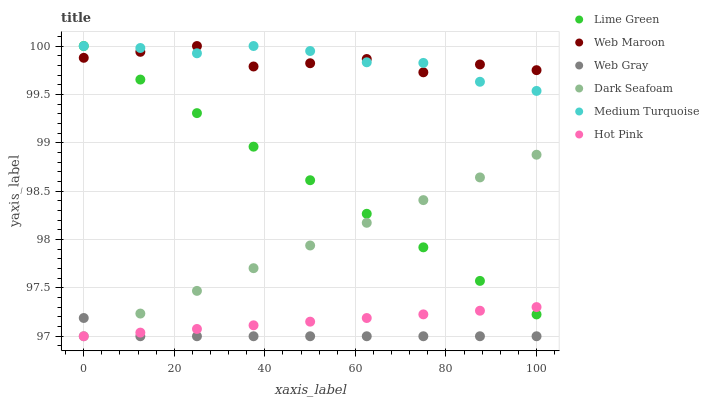Does Web Gray have the minimum area under the curve?
Answer yes or no. Yes. Does Medium Turquoise have the maximum area under the curve?
Answer yes or no. Yes. Does Hot Pink have the minimum area under the curve?
Answer yes or no. No. Does Hot Pink have the maximum area under the curve?
Answer yes or no. No. Is Dark Seafoam the smoothest?
Answer yes or no. Yes. Is Web Maroon the roughest?
Answer yes or no. Yes. Is Hot Pink the smoothest?
Answer yes or no. No. Is Hot Pink the roughest?
Answer yes or no. No. Does Web Gray have the lowest value?
Answer yes or no. Yes. Does Web Maroon have the lowest value?
Answer yes or no. No. Does Lime Green have the highest value?
Answer yes or no. Yes. Does Hot Pink have the highest value?
Answer yes or no. No. Is Web Gray less than Medium Turquoise?
Answer yes or no. Yes. Is Medium Turquoise greater than Hot Pink?
Answer yes or no. Yes. Does Lime Green intersect Dark Seafoam?
Answer yes or no. Yes. Is Lime Green less than Dark Seafoam?
Answer yes or no. No. Is Lime Green greater than Dark Seafoam?
Answer yes or no. No. Does Web Gray intersect Medium Turquoise?
Answer yes or no. No. 